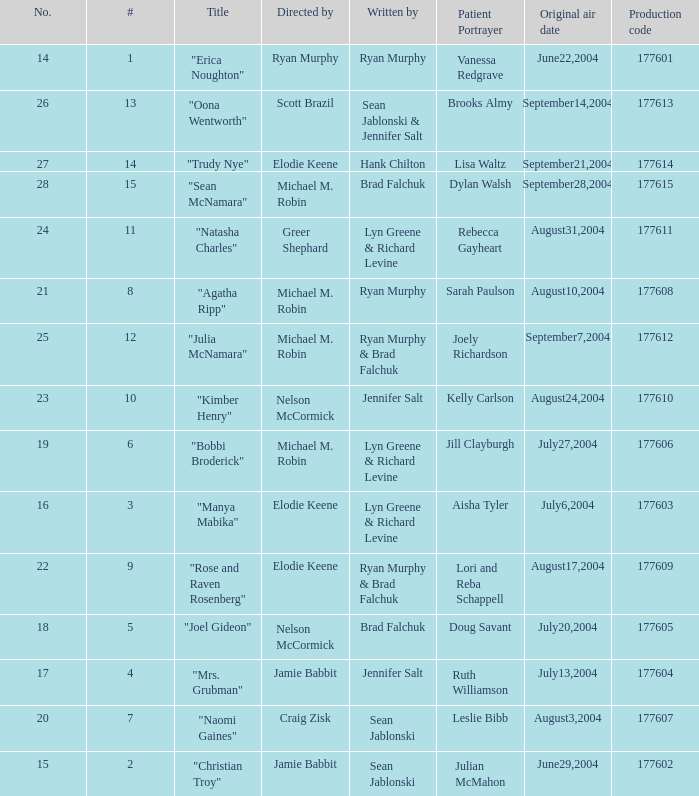Who directed the episode with production code 177605? Nelson McCormick. 